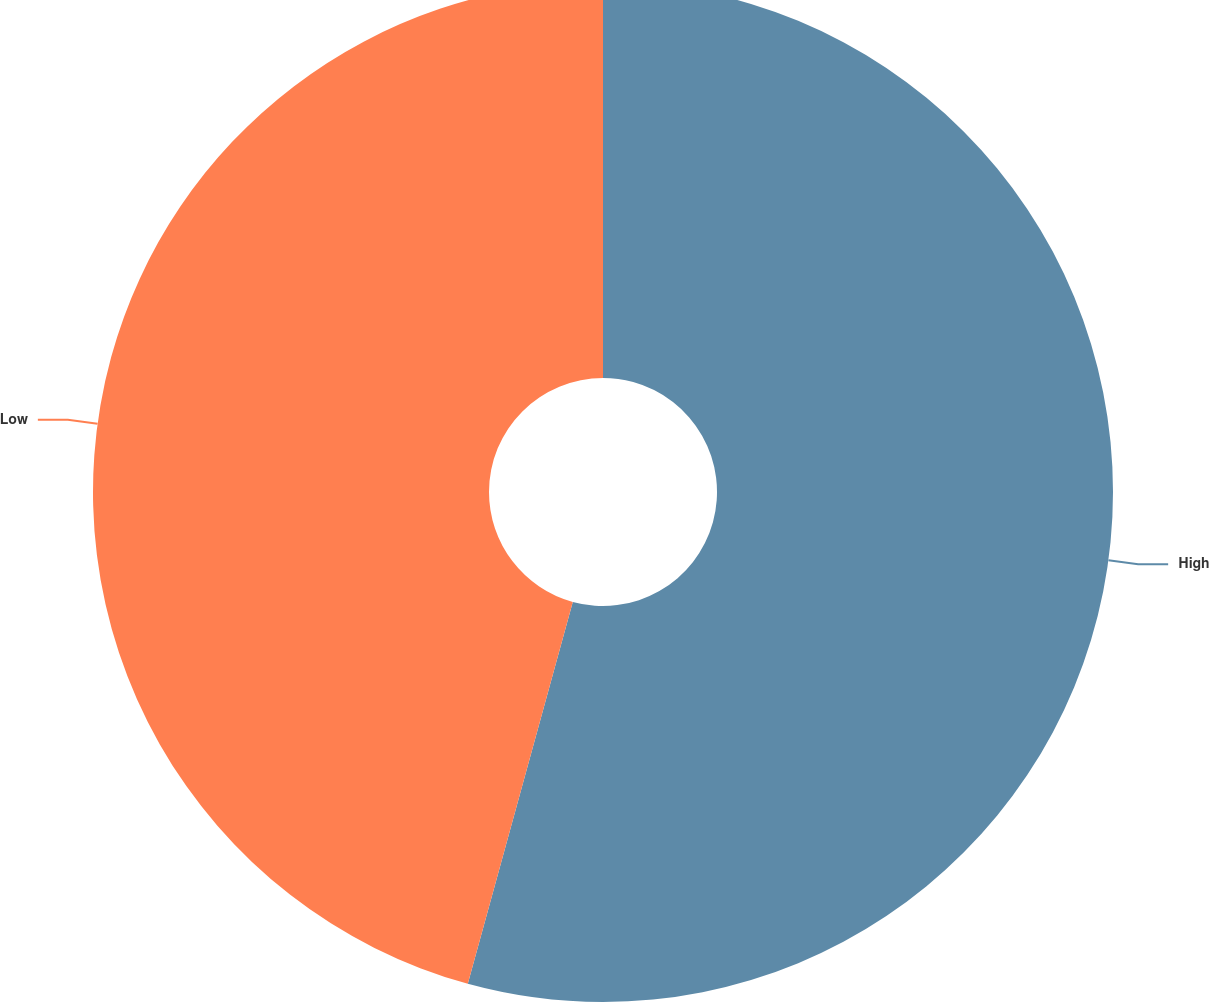<chart> <loc_0><loc_0><loc_500><loc_500><pie_chart><fcel>High<fcel>Low<nl><fcel>54.27%<fcel>45.73%<nl></chart> 